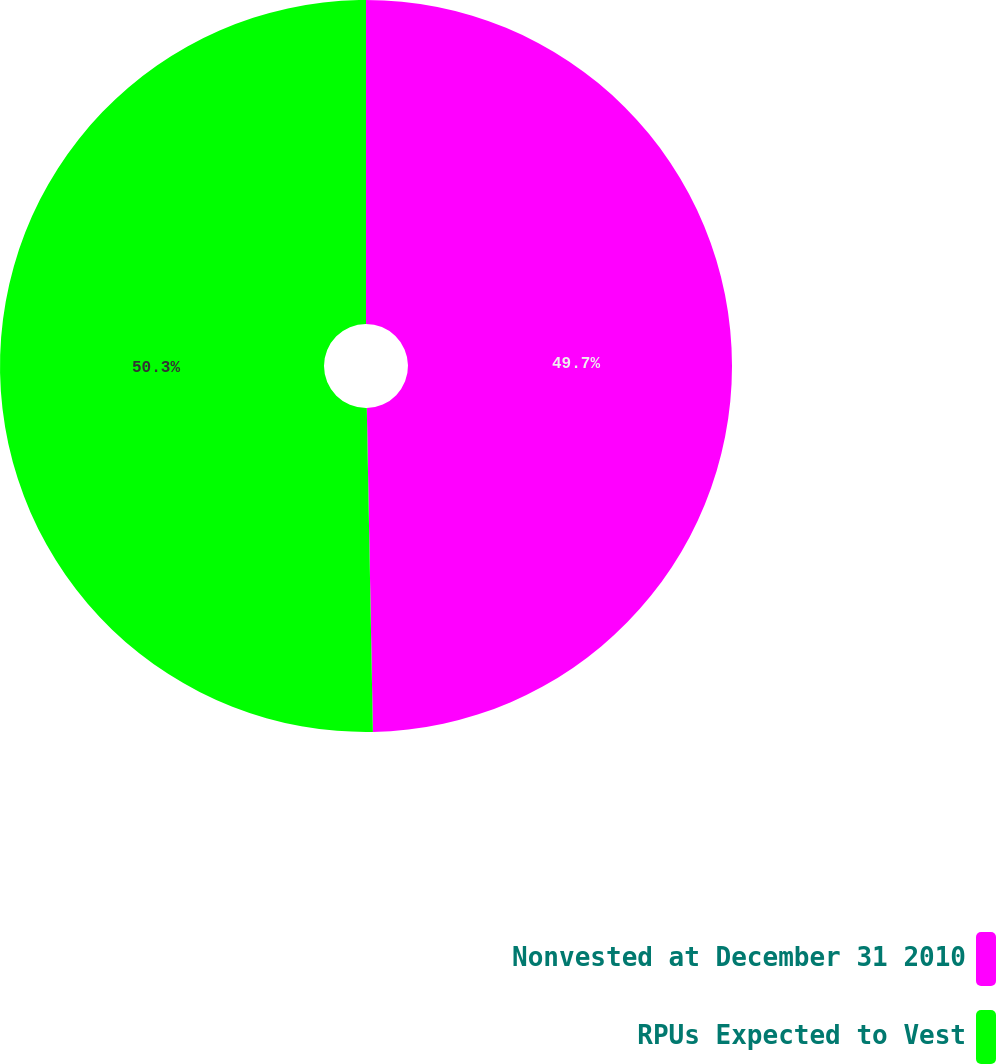Convert chart. <chart><loc_0><loc_0><loc_500><loc_500><pie_chart><fcel>Nonvested at December 31 2010<fcel>RPUs Expected to Vest<nl><fcel>49.7%<fcel>50.3%<nl></chart> 